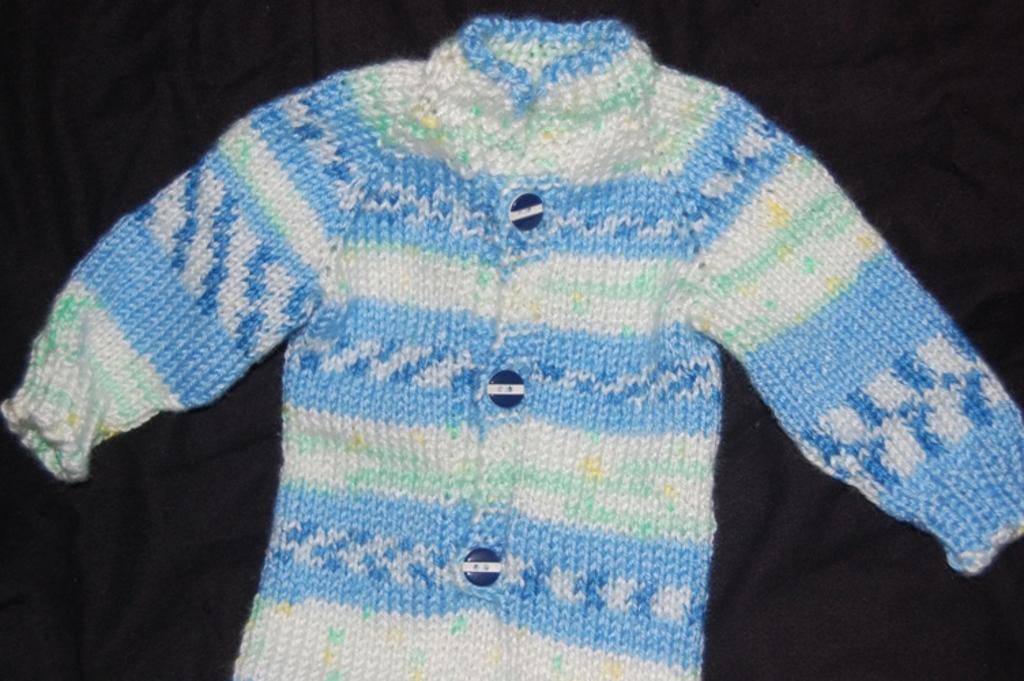In one or two sentences, can you explain what this image depicts? In this picture we can see a woolen sweater on a black cloth. 